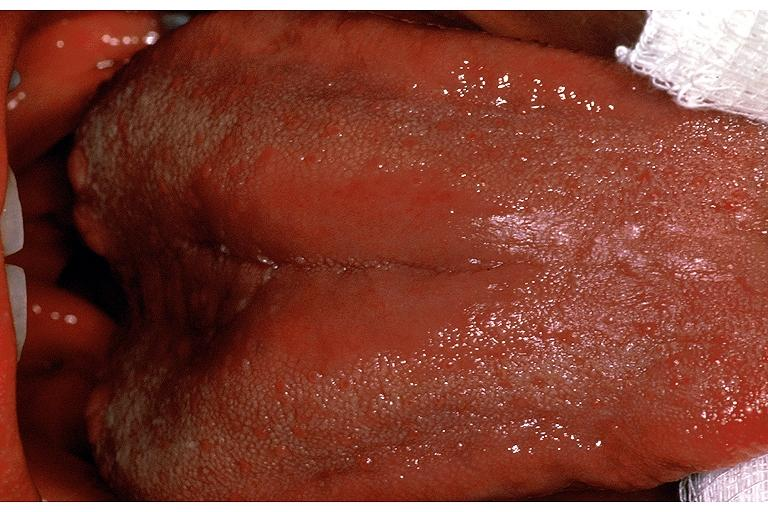where is this?
Answer the question using a single word or phrase. Oral 